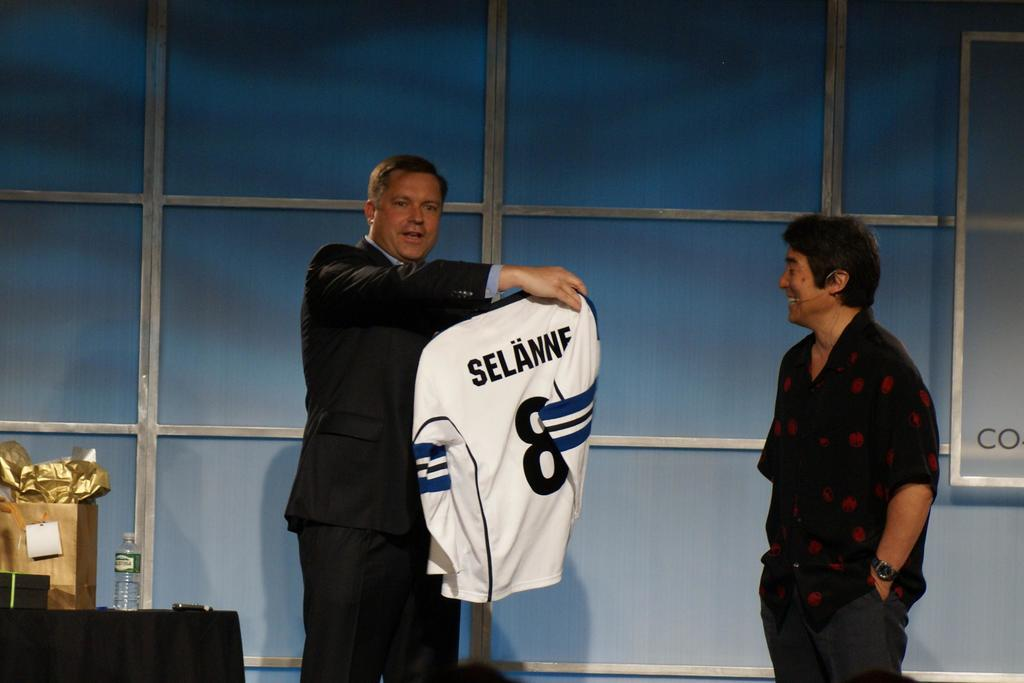<image>
Present a compact description of the photo's key features. a very nice jersey that has selanne on the back is nice. 